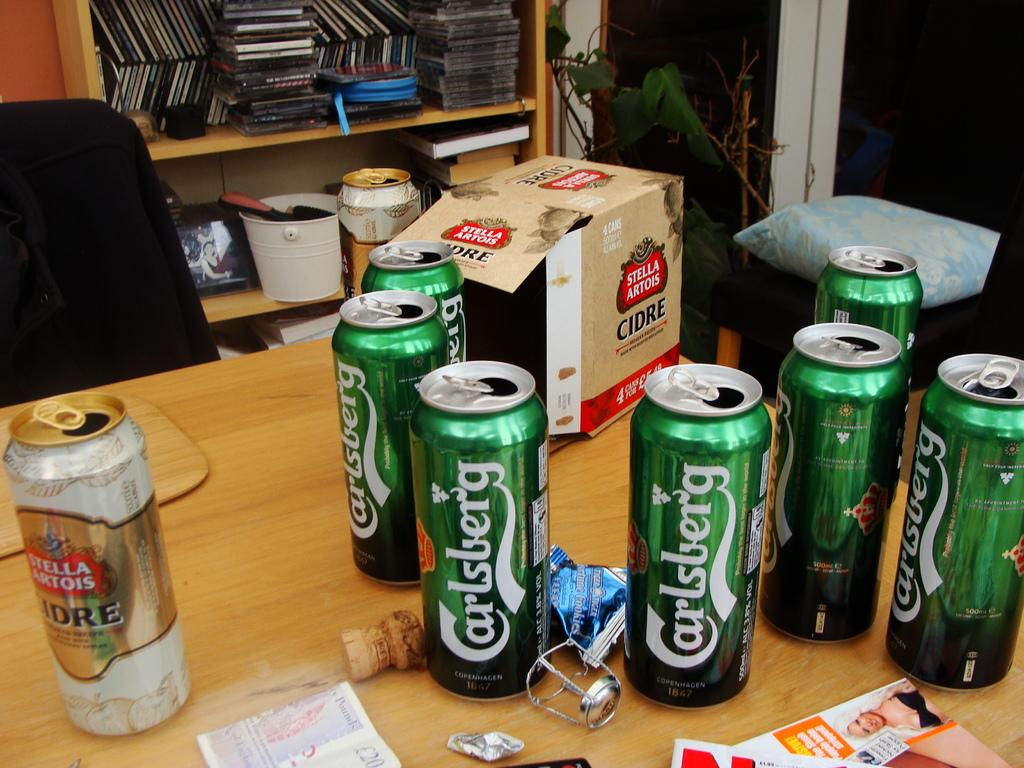Provide a one-sentence caption for the provided image. Several open cans of Carlsberg beer are on a desk. 